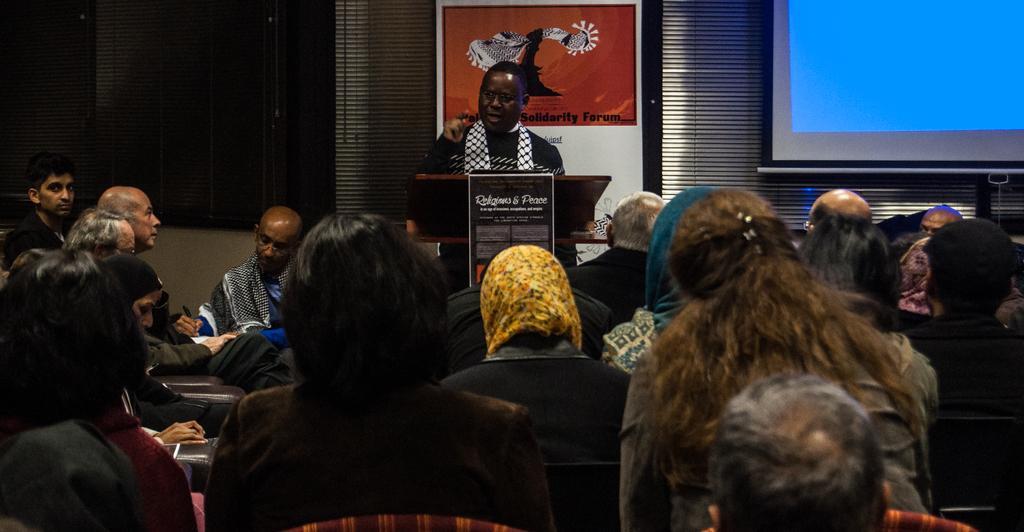Describe this image in one or two sentences. In the picture there are many people sitting on the chair, there is a person standing near the podium and talking, behind the person there is a frame on the wall, there is a screen on the wall. 